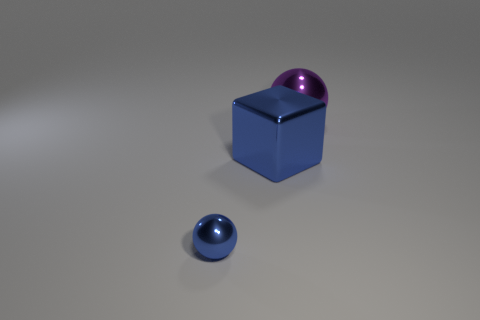There is a big shiny object behind the metal block; is it the same shape as the large object left of the large purple object?
Your response must be concise. No. Are there any blue cubes of the same size as the purple shiny thing?
Your response must be concise. Yes. Are there the same number of tiny blue objects that are to the right of the big blue metal thing and large purple objects that are to the right of the purple object?
Your response must be concise. Yes. Is the blue thing that is in front of the large metallic block made of the same material as the big object in front of the big purple metallic object?
Keep it short and to the point. Yes. What is the purple object made of?
Make the answer very short. Metal. How many other things are there of the same color as the block?
Give a very brief answer. 1. Do the cube and the tiny sphere have the same color?
Your answer should be very brief. Yes. How many tiny blue matte spheres are there?
Offer a very short reply. 0. There is a blue thing that is the same size as the purple metal thing; what is its material?
Ensure brevity in your answer.  Metal. Is the size of the ball left of the purple shiny ball the same as the purple sphere?
Ensure brevity in your answer.  No. 